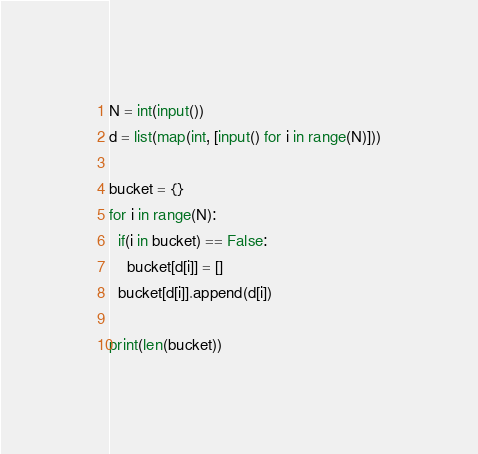Convert code to text. <code><loc_0><loc_0><loc_500><loc_500><_Python_>N = int(input())
d = list(map(int, [input() for i in range(N)]))

bucket = {}
for i in range(N):
  if(i in bucket) == False:
    bucket[d[i]] = []
  bucket[d[i]].append(d[i])

print(len(bucket))</code> 